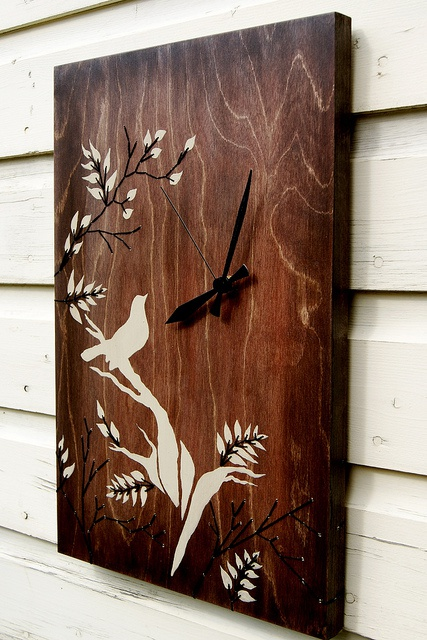Describe the objects in this image and their specific colors. I can see clock in white, maroon, black, and brown tones and bird in white, lightgray, beige, tan, and maroon tones in this image. 